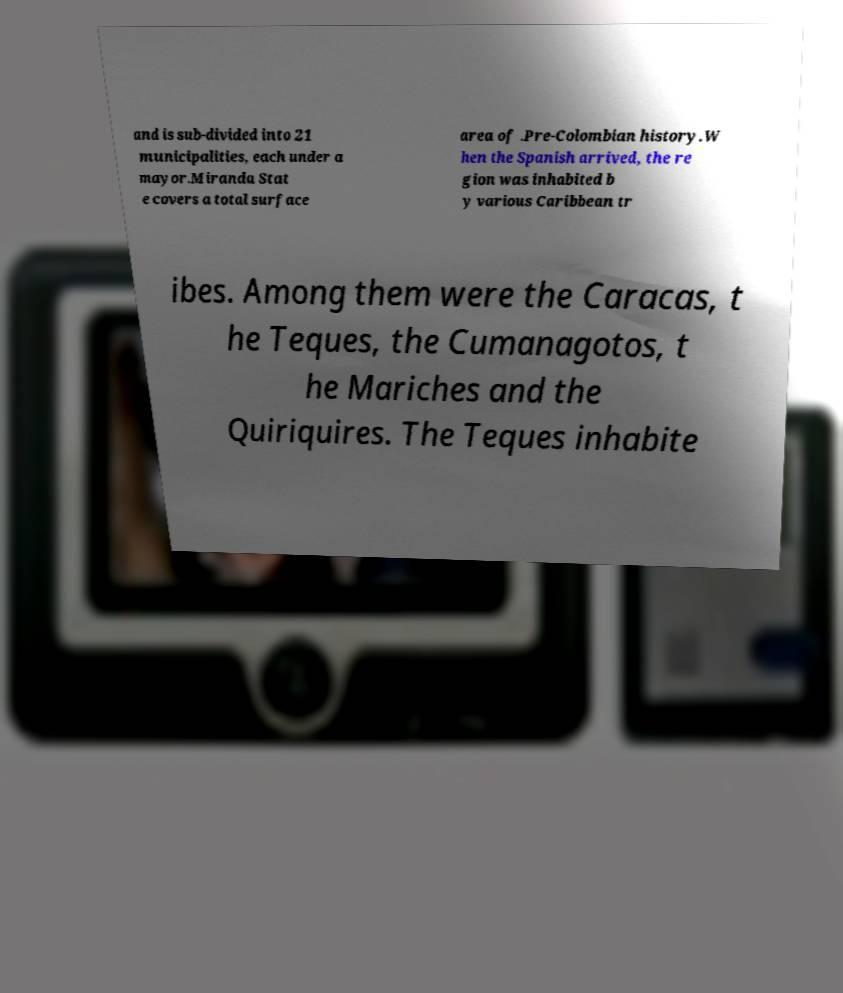Please identify and transcribe the text found in this image. and is sub-divided into 21 municipalities, each under a mayor.Miranda Stat e covers a total surface area of .Pre-Colombian history.W hen the Spanish arrived, the re gion was inhabited b y various Caribbean tr ibes. Among them were the Caracas, t he Teques, the Cumanagotos, t he Mariches and the Quiriquires. The Teques inhabite 